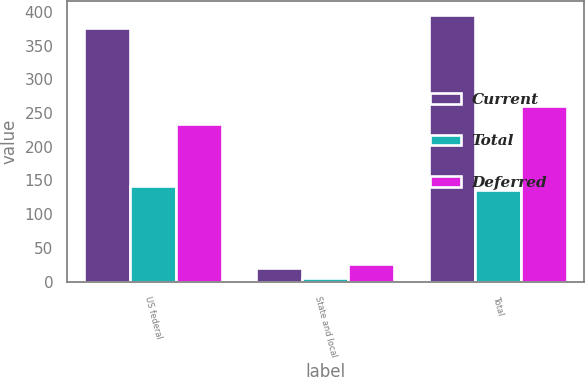Convert chart. <chart><loc_0><loc_0><loc_500><loc_500><stacked_bar_chart><ecel><fcel>US federal<fcel>State and local<fcel>Total<nl><fcel>Current<fcel>376<fcel>20<fcel>396<nl><fcel>Total<fcel>142<fcel>6<fcel>136<nl><fcel>Deferred<fcel>234<fcel>26<fcel>260<nl></chart> 